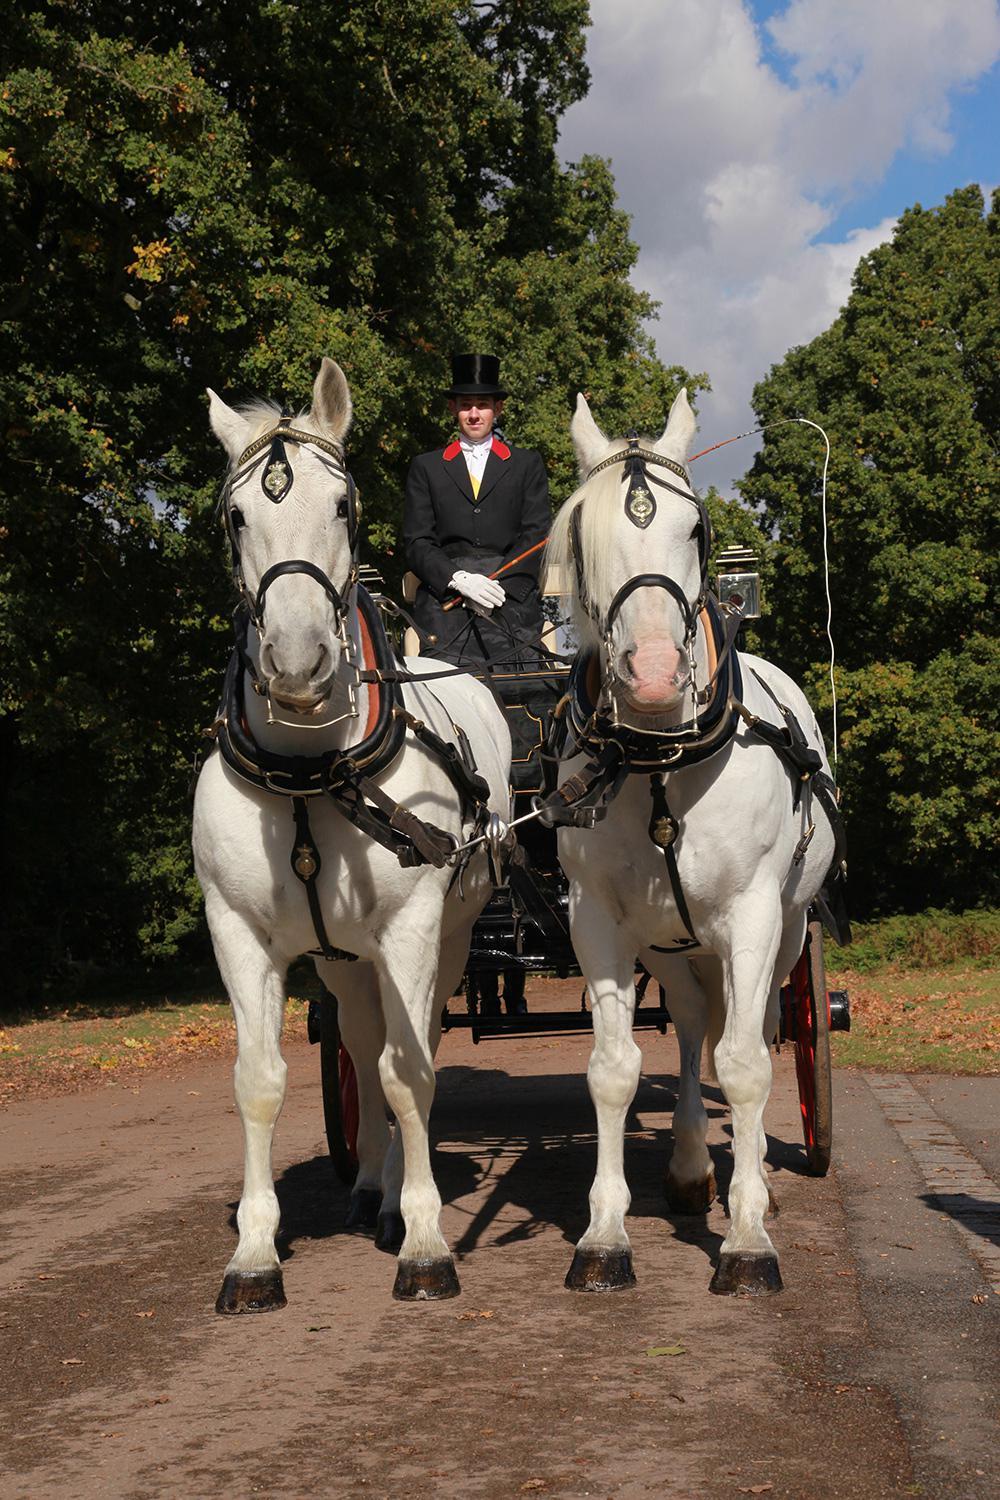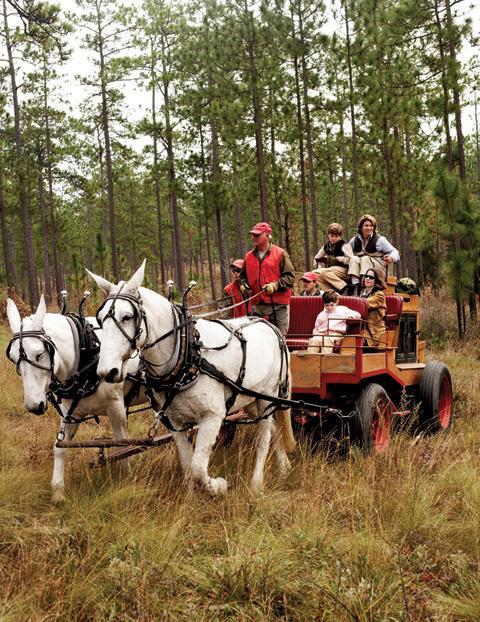The first image is the image on the left, the second image is the image on the right. Analyze the images presented: Is the assertion "At least one image shows a cart pulled by exactly two white horses." valid? Answer yes or no. Yes. The first image is the image on the left, the second image is the image on the right. For the images shown, is this caption "There are two white horses in the image on the left." true? Answer yes or no. Yes. 